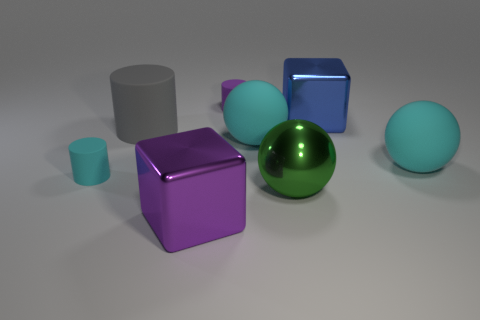Is there anything else that has the same shape as the blue object?
Give a very brief answer. Yes. Do the tiny thing that is behind the blue thing and the large metal block that is right of the big purple thing have the same color?
Offer a very short reply. No. How many metallic objects are small brown cylinders or purple things?
Give a very brief answer. 1. There is a large cyan rubber thing that is to the right of the blue thing right of the cyan cylinder; what is its shape?
Your answer should be compact. Sphere. Is the material of the purple object that is in front of the small purple rubber cylinder the same as the big ball that is on the left side of the green object?
Your answer should be compact. No. There is a tiny cylinder that is in front of the purple matte cylinder; how many small rubber things are in front of it?
Provide a short and direct response. 0. Do the big shiny object that is left of the purple rubber cylinder and the big metallic thing that is behind the cyan cylinder have the same shape?
Your response must be concise. Yes. What is the size of the object that is both in front of the large gray matte thing and to the left of the large purple object?
Provide a succinct answer. Small. There is another small thing that is the same shape as the purple rubber object; what color is it?
Your answer should be compact. Cyan. What is the color of the block on the right side of the purple thing in front of the big blue metal thing?
Make the answer very short. Blue. 